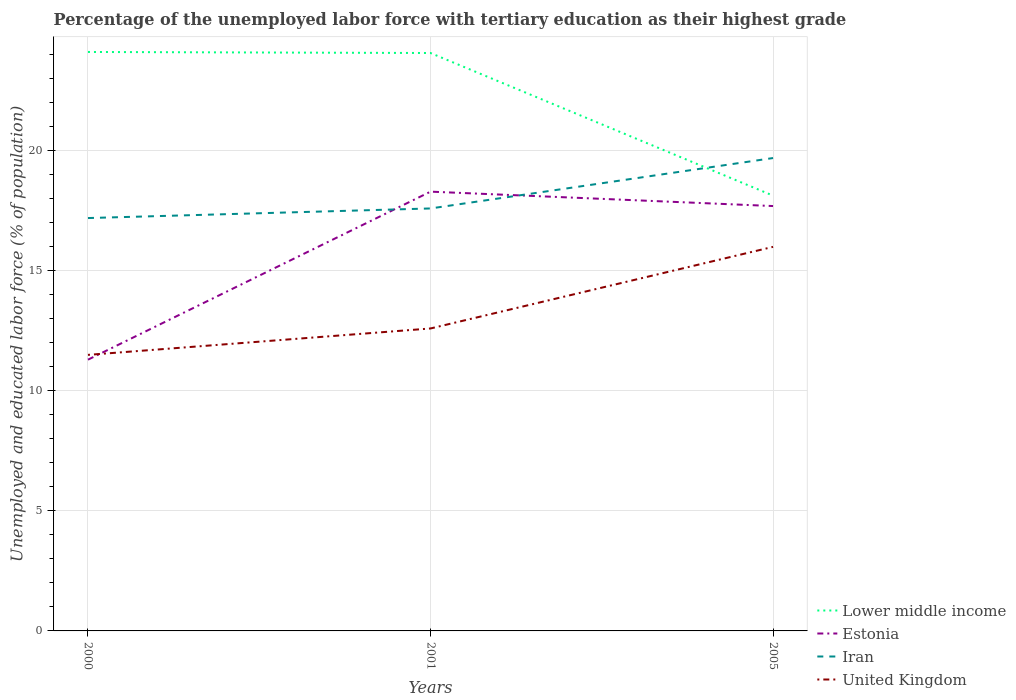Does the line corresponding to Estonia intersect with the line corresponding to Iran?
Give a very brief answer. Yes. Is the number of lines equal to the number of legend labels?
Ensure brevity in your answer.  Yes. What is the total percentage of the unemployed labor force with tertiary education in United Kingdom in the graph?
Your answer should be compact. -1.1. What is the difference between the highest and the second highest percentage of the unemployed labor force with tertiary education in United Kingdom?
Keep it short and to the point. 4.5. What is the difference between the highest and the lowest percentage of the unemployed labor force with tertiary education in Lower middle income?
Offer a very short reply. 2. Are the values on the major ticks of Y-axis written in scientific E-notation?
Make the answer very short. No. Does the graph contain grids?
Offer a very short reply. Yes. How are the legend labels stacked?
Provide a short and direct response. Vertical. What is the title of the graph?
Your answer should be very brief. Percentage of the unemployed labor force with tertiary education as their highest grade. What is the label or title of the Y-axis?
Offer a very short reply. Unemployed and educated labor force (% of population). What is the Unemployed and educated labor force (% of population) in Lower middle income in 2000?
Your response must be concise. 24.12. What is the Unemployed and educated labor force (% of population) of Estonia in 2000?
Give a very brief answer. 11.3. What is the Unemployed and educated labor force (% of population) in Iran in 2000?
Ensure brevity in your answer.  17.2. What is the Unemployed and educated labor force (% of population) of United Kingdom in 2000?
Your answer should be compact. 11.5. What is the Unemployed and educated labor force (% of population) of Lower middle income in 2001?
Ensure brevity in your answer.  24.08. What is the Unemployed and educated labor force (% of population) of Estonia in 2001?
Your answer should be very brief. 18.3. What is the Unemployed and educated labor force (% of population) in Iran in 2001?
Give a very brief answer. 17.6. What is the Unemployed and educated labor force (% of population) of United Kingdom in 2001?
Your answer should be very brief. 12.6. What is the Unemployed and educated labor force (% of population) of Lower middle income in 2005?
Keep it short and to the point. 18.13. What is the Unemployed and educated labor force (% of population) of Estonia in 2005?
Provide a short and direct response. 17.7. What is the Unemployed and educated labor force (% of population) of Iran in 2005?
Provide a short and direct response. 19.7. What is the Unemployed and educated labor force (% of population) in United Kingdom in 2005?
Your answer should be very brief. 16. Across all years, what is the maximum Unemployed and educated labor force (% of population) in Lower middle income?
Ensure brevity in your answer.  24.12. Across all years, what is the maximum Unemployed and educated labor force (% of population) of Estonia?
Your answer should be very brief. 18.3. Across all years, what is the maximum Unemployed and educated labor force (% of population) of Iran?
Provide a succinct answer. 19.7. Across all years, what is the minimum Unemployed and educated labor force (% of population) in Lower middle income?
Give a very brief answer. 18.13. Across all years, what is the minimum Unemployed and educated labor force (% of population) of Estonia?
Your answer should be compact. 11.3. Across all years, what is the minimum Unemployed and educated labor force (% of population) in Iran?
Your response must be concise. 17.2. Across all years, what is the minimum Unemployed and educated labor force (% of population) in United Kingdom?
Give a very brief answer. 11.5. What is the total Unemployed and educated labor force (% of population) of Lower middle income in the graph?
Offer a very short reply. 66.33. What is the total Unemployed and educated labor force (% of population) in Estonia in the graph?
Your answer should be compact. 47.3. What is the total Unemployed and educated labor force (% of population) in Iran in the graph?
Keep it short and to the point. 54.5. What is the total Unemployed and educated labor force (% of population) in United Kingdom in the graph?
Provide a succinct answer. 40.1. What is the difference between the Unemployed and educated labor force (% of population) of Lower middle income in 2000 and that in 2001?
Provide a succinct answer. 0.04. What is the difference between the Unemployed and educated labor force (% of population) in Estonia in 2000 and that in 2001?
Your answer should be compact. -7. What is the difference between the Unemployed and educated labor force (% of population) in Iran in 2000 and that in 2001?
Offer a terse response. -0.4. What is the difference between the Unemployed and educated labor force (% of population) in Lower middle income in 2000 and that in 2005?
Keep it short and to the point. 5.99. What is the difference between the Unemployed and educated labor force (% of population) of Iran in 2000 and that in 2005?
Keep it short and to the point. -2.5. What is the difference between the Unemployed and educated labor force (% of population) of Lower middle income in 2001 and that in 2005?
Provide a succinct answer. 5.94. What is the difference between the Unemployed and educated labor force (% of population) of Estonia in 2001 and that in 2005?
Give a very brief answer. 0.6. What is the difference between the Unemployed and educated labor force (% of population) of Iran in 2001 and that in 2005?
Ensure brevity in your answer.  -2.1. What is the difference between the Unemployed and educated labor force (% of population) in United Kingdom in 2001 and that in 2005?
Provide a succinct answer. -3.4. What is the difference between the Unemployed and educated labor force (% of population) in Lower middle income in 2000 and the Unemployed and educated labor force (% of population) in Estonia in 2001?
Ensure brevity in your answer.  5.82. What is the difference between the Unemployed and educated labor force (% of population) of Lower middle income in 2000 and the Unemployed and educated labor force (% of population) of Iran in 2001?
Your answer should be very brief. 6.52. What is the difference between the Unemployed and educated labor force (% of population) in Lower middle income in 2000 and the Unemployed and educated labor force (% of population) in United Kingdom in 2001?
Your response must be concise. 11.52. What is the difference between the Unemployed and educated labor force (% of population) of Estonia in 2000 and the Unemployed and educated labor force (% of population) of Iran in 2001?
Provide a succinct answer. -6.3. What is the difference between the Unemployed and educated labor force (% of population) of Lower middle income in 2000 and the Unemployed and educated labor force (% of population) of Estonia in 2005?
Ensure brevity in your answer.  6.42. What is the difference between the Unemployed and educated labor force (% of population) in Lower middle income in 2000 and the Unemployed and educated labor force (% of population) in Iran in 2005?
Provide a succinct answer. 4.42. What is the difference between the Unemployed and educated labor force (% of population) of Lower middle income in 2000 and the Unemployed and educated labor force (% of population) of United Kingdom in 2005?
Your answer should be very brief. 8.12. What is the difference between the Unemployed and educated labor force (% of population) of Lower middle income in 2001 and the Unemployed and educated labor force (% of population) of Estonia in 2005?
Your answer should be compact. 6.38. What is the difference between the Unemployed and educated labor force (% of population) in Lower middle income in 2001 and the Unemployed and educated labor force (% of population) in Iran in 2005?
Your answer should be compact. 4.38. What is the difference between the Unemployed and educated labor force (% of population) of Lower middle income in 2001 and the Unemployed and educated labor force (% of population) of United Kingdom in 2005?
Keep it short and to the point. 8.08. What is the difference between the Unemployed and educated labor force (% of population) of Estonia in 2001 and the Unemployed and educated labor force (% of population) of Iran in 2005?
Offer a terse response. -1.4. What is the difference between the Unemployed and educated labor force (% of population) in Estonia in 2001 and the Unemployed and educated labor force (% of population) in United Kingdom in 2005?
Offer a terse response. 2.3. What is the average Unemployed and educated labor force (% of population) of Lower middle income per year?
Keep it short and to the point. 22.11. What is the average Unemployed and educated labor force (% of population) of Estonia per year?
Offer a terse response. 15.77. What is the average Unemployed and educated labor force (% of population) in Iran per year?
Your response must be concise. 18.17. What is the average Unemployed and educated labor force (% of population) in United Kingdom per year?
Ensure brevity in your answer.  13.37. In the year 2000, what is the difference between the Unemployed and educated labor force (% of population) of Lower middle income and Unemployed and educated labor force (% of population) of Estonia?
Provide a succinct answer. 12.82. In the year 2000, what is the difference between the Unemployed and educated labor force (% of population) in Lower middle income and Unemployed and educated labor force (% of population) in Iran?
Your answer should be compact. 6.92. In the year 2000, what is the difference between the Unemployed and educated labor force (% of population) of Lower middle income and Unemployed and educated labor force (% of population) of United Kingdom?
Your response must be concise. 12.62. In the year 2000, what is the difference between the Unemployed and educated labor force (% of population) in Estonia and Unemployed and educated labor force (% of population) in Iran?
Make the answer very short. -5.9. In the year 2000, what is the difference between the Unemployed and educated labor force (% of population) of Estonia and Unemployed and educated labor force (% of population) of United Kingdom?
Provide a short and direct response. -0.2. In the year 2000, what is the difference between the Unemployed and educated labor force (% of population) of Iran and Unemployed and educated labor force (% of population) of United Kingdom?
Give a very brief answer. 5.7. In the year 2001, what is the difference between the Unemployed and educated labor force (% of population) in Lower middle income and Unemployed and educated labor force (% of population) in Estonia?
Keep it short and to the point. 5.78. In the year 2001, what is the difference between the Unemployed and educated labor force (% of population) of Lower middle income and Unemployed and educated labor force (% of population) of Iran?
Offer a terse response. 6.48. In the year 2001, what is the difference between the Unemployed and educated labor force (% of population) in Lower middle income and Unemployed and educated labor force (% of population) in United Kingdom?
Ensure brevity in your answer.  11.48. In the year 2001, what is the difference between the Unemployed and educated labor force (% of population) in Estonia and Unemployed and educated labor force (% of population) in Iran?
Offer a terse response. 0.7. In the year 2001, what is the difference between the Unemployed and educated labor force (% of population) in Estonia and Unemployed and educated labor force (% of population) in United Kingdom?
Offer a very short reply. 5.7. In the year 2001, what is the difference between the Unemployed and educated labor force (% of population) of Iran and Unemployed and educated labor force (% of population) of United Kingdom?
Offer a terse response. 5. In the year 2005, what is the difference between the Unemployed and educated labor force (% of population) of Lower middle income and Unemployed and educated labor force (% of population) of Estonia?
Give a very brief answer. 0.43. In the year 2005, what is the difference between the Unemployed and educated labor force (% of population) of Lower middle income and Unemployed and educated labor force (% of population) of Iran?
Provide a succinct answer. -1.57. In the year 2005, what is the difference between the Unemployed and educated labor force (% of population) in Lower middle income and Unemployed and educated labor force (% of population) in United Kingdom?
Your answer should be compact. 2.13. In the year 2005, what is the difference between the Unemployed and educated labor force (% of population) of Estonia and Unemployed and educated labor force (% of population) of Iran?
Give a very brief answer. -2. In the year 2005, what is the difference between the Unemployed and educated labor force (% of population) of Estonia and Unemployed and educated labor force (% of population) of United Kingdom?
Give a very brief answer. 1.7. What is the ratio of the Unemployed and educated labor force (% of population) in Lower middle income in 2000 to that in 2001?
Keep it short and to the point. 1. What is the ratio of the Unemployed and educated labor force (% of population) in Estonia in 2000 to that in 2001?
Ensure brevity in your answer.  0.62. What is the ratio of the Unemployed and educated labor force (% of population) of Iran in 2000 to that in 2001?
Offer a very short reply. 0.98. What is the ratio of the Unemployed and educated labor force (% of population) in United Kingdom in 2000 to that in 2001?
Give a very brief answer. 0.91. What is the ratio of the Unemployed and educated labor force (% of population) of Lower middle income in 2000 to that in 2005?
Provide a succinct answer. 1.33. What is the ratio of the Unemployed and educated labor force (% of population) in Estonia in 2000 to that in 2005?
Offer a very short reply. 0.64. What is the ratio of the Unemployed and educated labor force (% of population) in Iran in 2000 to that in 2005?
Offer a terse response. 0.87. What is the ratio of the Unemployed and educated labor force (% of population) of United Kingdom in 2000 to that in 2005?
Offer a very short reply. 0.72. What is the ratio of the Unemployed and educated labor force (% of population) of Lower middle income in 2001 to that in 2005?
Provide a short and direct response. 1.33. What is the ratio of the Unemployed and educated labor force (% of population) of Estonia in 2001 to that in 2005?
Keep it short and to the point. 1.03. What is the ratio of the Unemployed and educated labor force (% of population) in Iran in 2001 to that in 2005?
Your answer should be compact. 0.89. What is the ratio of the Unemployed and educated labor force (% of population) in United Kingdom in 2001 to that in 2005?
Make the answer very short. 0.79. What is the difference between the highest and the second highest Unemployed and educated labor force (% of population) in Lower middle income?
Your answer should be very brief. 0.04. What is the difference between the highest and the second highest Unemployed and educated labor force (% of population) in Estonia?
Keep it short and to the point. 0.6. What is the difference between the highest and the second highest Unemployed and educated labor force (% of population) in United Kingdom?
Offer a terse response. 3.4. What is the difference between the highest and the lowest Unemployed and educated labor force (% of population) in Lower middle income?
Offer a very short reply. 5.99. What is the difference between the highest and the lowest Unemployed and educated labor force (% of population) in United Kingdom?
Provide a short and direct response. 4.5. 